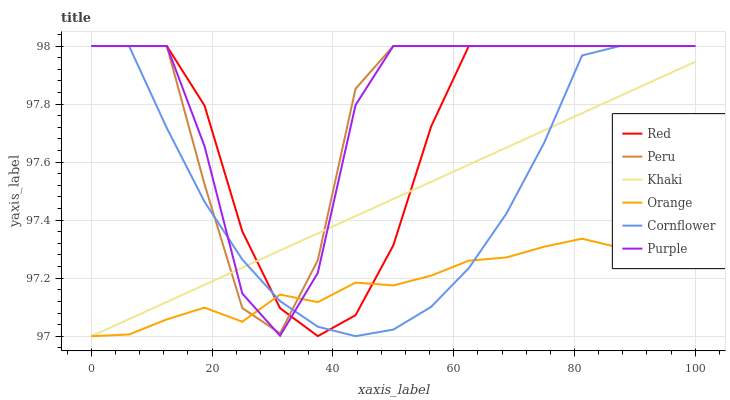Does Khaki have the minimum area under the curve?
Answer yes or no. No. Does Khaki have the maximum area under the curve?
Answer yes or no. No. Is Purple the smoothest?
Answer yes or no. No. Is Khaki the roughest?
Answer yes or no. No. Does Purple have the lowest value?
Answer yes or no. No. Does Khaki have the highest value?
Answer yes or no. No. 